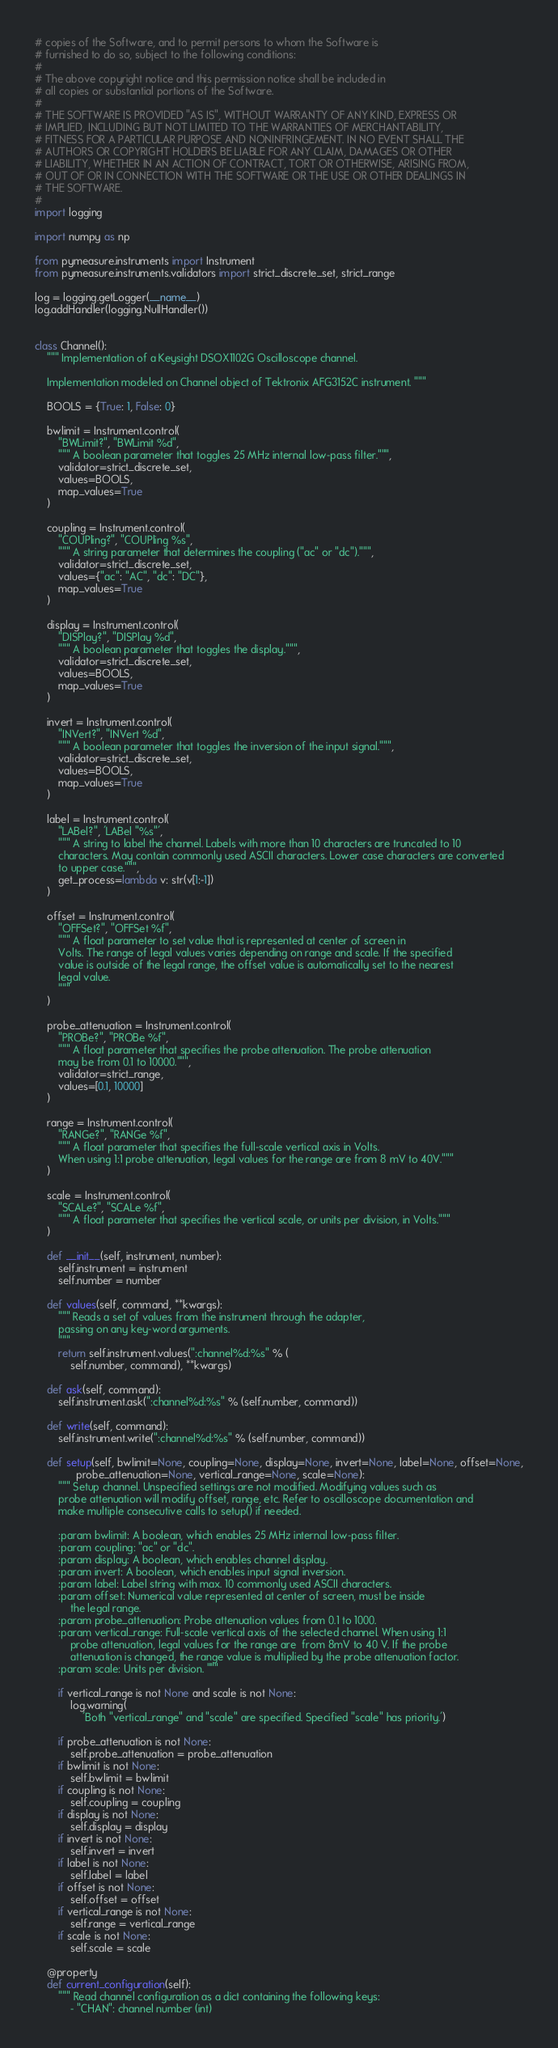Convert code to text. <code><loc_0><loc_0><loc_500><loc_500><_Python_># copies of the Software, and to permit persons to whom the Software is
# furnished to do so, subject to the following conditions:
#
# The above copyright notice and this permission notice shall be included in
# all copies or substantial portions of the Software.
#
# THE SOFTWARE IS PROVIDED "AS IS", WITHOUT WARRANTY OF ANY KIND, EXPRESS OR
# IMPLIED, INCLUDING BUT NOT LIMITED TO THE WARRANTIES OF MERCHANTABILITY,
# FITNESS FOR A PARTICULAR PURPOSE AND NONINFRINGEMENT. IN NO EVENT SHALL THE
# AUTHORS OR COPYRIGHT HOLDERS BE LIABLE FOR ANY CLAIM, DAMAGES OR OTHER
# LIABILITY, WHETHER IN AN ACTION OF CONTRACT, TORT OR OTHERWISE, ARISING FROM,
# OUT OF OR IN CONNECTION WITH THE SOFTWARE OR THE USE OR OTHER DEALINGS IN
# THE SOFTWARE.
#
import logging

import numpy as np

from pymeasure.instruments import Instrument
from pymeasure.instruments.validators import strict_discrete_set, strict_range

log = logging.getLogger(__name__)
log.addHandler(logging.NullHandler())


class Channel():
    """ Implementation of a Keysight DSOX1102G Oscilloscope channel.

    Implementation modeled on Channel object of Tektronix AFG3152C instrument. """

    BOOLS = {True: 1, False: 0}

    bwlimit = Instrument.control(
        "BWLimit?", "BWLimit %d",
        """ A boolean parameter that toggles 25 MHz internal low-pass filter.""",
        validator=strict_discrete_set,
        values=BOOLS,
        map_values=True
    )

    coupling = Instrument.control(
        "COUPling?", "COUPling %s",
        """ A string parameter that determines the coupling ("ac" or "dc").""",
        validator=strict_discrete_set,
        values={"ac": "AC", "dc": "DC"},
        map_values=True
    )

    display = Instrument.control(
        "DISPlay?", "DISPlay %d",
        """ A boolean parameter that toggles the display.""",
        validator=strict_discrete_set,
        values=BOOLS,
        map_values=True
    )

    invert = Instrument.control(
        "INVert?", "INVert %d",
        """ A boolean parameter that toggles the inversion of the input signal.""",
        validator=strict_discrete_set,
        values=BOOLS,
        map_values=True
    )

    label = Instrument.control(
        "LABel?", 'LABel "%s"',
        """ A string to label the channel. Labels with more than 10 characters are truncated to 10
        characters. May contain commonly used ASCII characters. Lower case characters are converted
        to upper case.""",
        get_process=lambda v: str(v[1:-1])
    )

    offset = Instrument.control(
        "OFFSet?", "OFFSet %f",
        """ A float parameter to set value that is represented at center of screen in
        Volts. The range of legal values varies depending on range and scale. If the specified
        value is outside of the legal range, the offset value is automatically set to the nearest
        legal value.
        """
    )

    probe_attenuation = Instrument.control(
        "PROBe?", "PROBe %f",
        """ A float parameter that specifies the probe attenuation. The probe attenuation
        may be from 0.1 to 10000.""",
        validator=strict_range,
        values=[0.1, 10000]
    )

    range = Instrument.control(
        "RANGe?", "RANGe %f",
        """ A float parameter that specifies the full-scale vertical axis in Volts.
        When using 1:1 probe attenuation, legal values for the range are from 8 mV to 40V."""
    )

    scale = Instrument.control(
        "SCALe?", "SCALe %f",
        """ A float parameter that specifies the vertical scale, or units per division, in Volts."""
    )

    def __init__(self, instrument, number):
        self.instrument = instrument
        self.number = number

    def values(self, command, **kwargs):
        """ Reads a set of values from the instrument through the adapter,
        passing on any key-word arguments.
        """
        return self.instrument.values(":channel%d:%s" % (
            self.number, command), **kwargs)

    def ask(self, command):
        self.instrument.ask(":channel%d:%s" % (self.number, command))

    def write(self, command):
        self.instrument.write(":channel%d:%s" % (self.number, command))

    def setup(self, bwlimit=None, coupling=None, display=None, invert=None, label=None, offset=None,
              probe_attenuation=None, vertical_range=None, scale=None):
        """ Setup channel. Unspecified settings are not modified. Modifying values such as
        probe attenuation will modify offset, range, etc. Refer to oscilloscope documentation and
        make multiple consecutive calls to setup() if needed.

        :param bwlimit: A boolean, which enables 25 MHz internal low-pass filter.
        :param coupling: "ac" or "dc".
        :param display: A boolean, which enables channel display.
        :param invert: A boolean, which enables input signal inversion.
        :param label: Label string with max. 10 commonly used ASCII characters.
        :param offset: Numerical value represented at center of screen, must be inside
            the legal range.
        :param probe_attenuation: Probe attenuation values from 0.1 to 1000.
        :param vertical_range: Full-scale vertical axis of the selected channel. When using 1:1
            probe attenuation, legal values for the range are  from 8mV to 40 V. If the probe
            attenuation is changed, the range value is multiplied by the probe attenuation factor.
        :param scale: Units per division. """

        if vertical_range is not None and scale is not None:
            log.warning(
                'Both "vertical_range" and "scale" are specified. Specified "scale" has priority.')

        if probe_attenuation is not None:
            self.probe_attenuation = probe_attenuation
        if bwlimit is not None:
            self.bwlimit = bwlimit
        if coupling is not None:
            self.coupling = coupling
        if display is not None:
            self.display = display
        if invert is not None:
            self.invert = invert
        if label is not None:
            self.label = label
        if offset is not None:
            self.offset = offset
        if vertical_range is not None:
            self.range = vertical_range
        if scale is not None:
            self.scale = scale

    @property
    def current_configuration(self):
        """ Read channel configuration as a dict containing the following keys:
            - "CHAN": channel number (int)</code> 